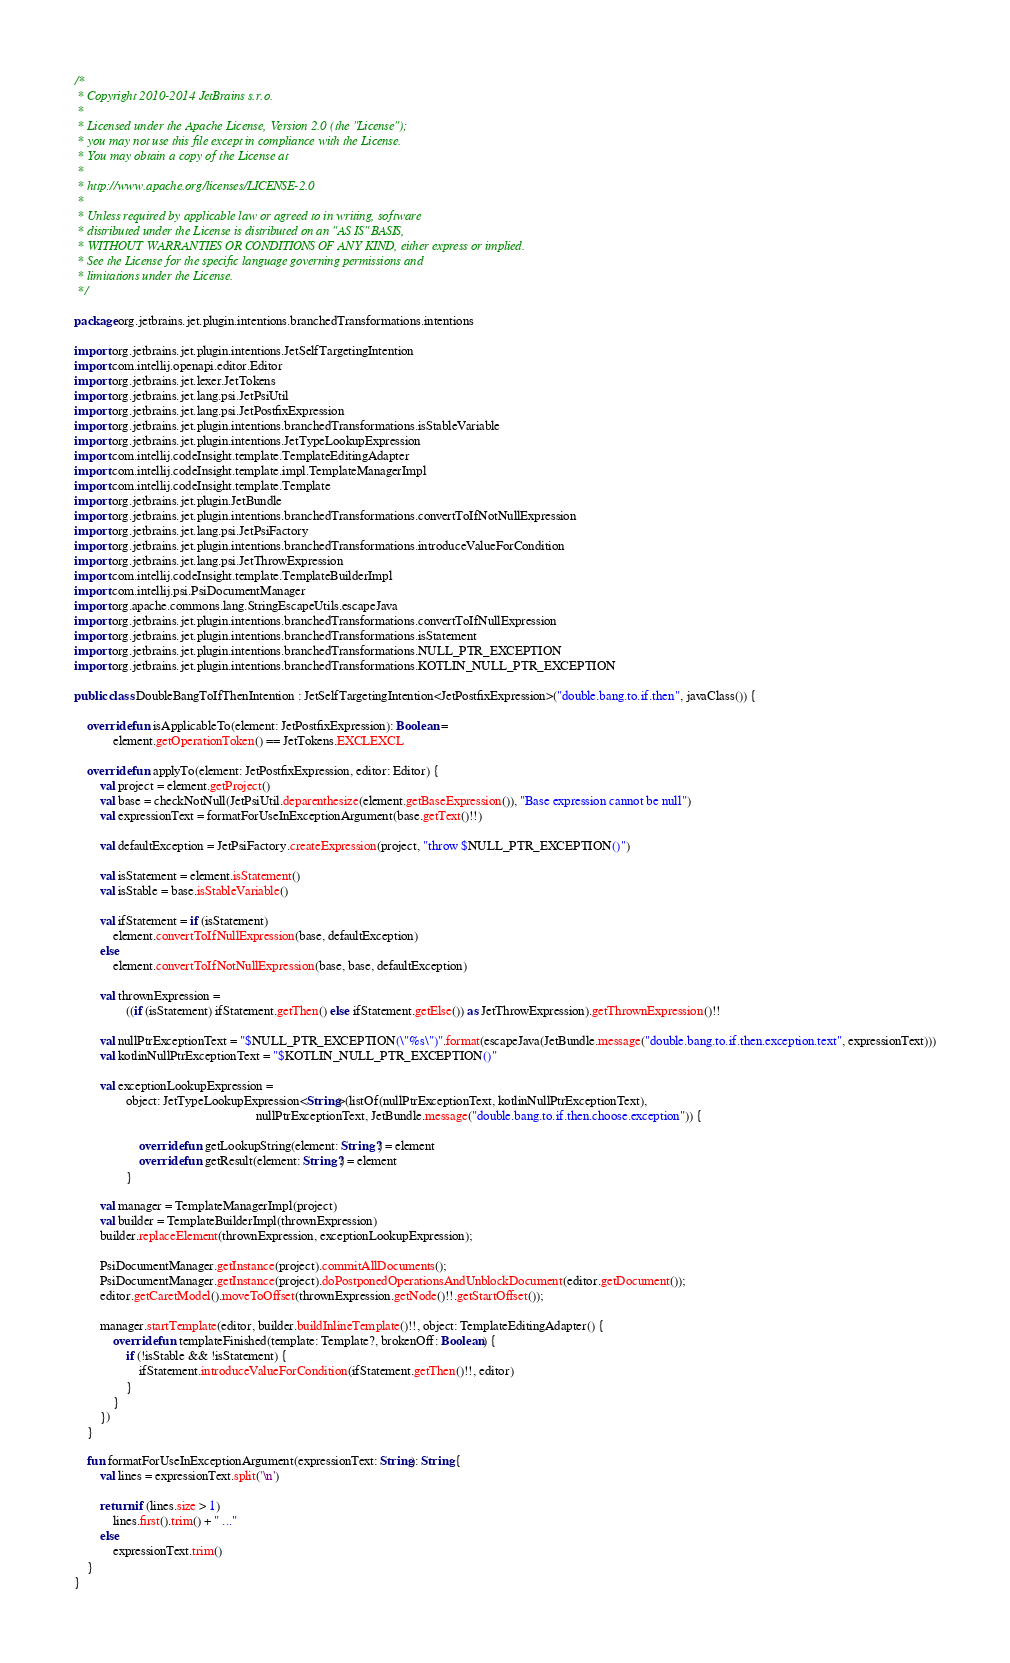<code> <loc_0><loc_0><loc_500><loc_500><_Kotlin_>/*
 * Copyright 2010-2014 JetBrains s.r.o.
 *
 * Licensed under the Apache License, Version 2.0 (the "License");
 * you may not use this file except in compliance with the License.
 * You may obtain a copy of the License at
 *
 * http://www.apache.org/licenses/LICENSE-2.0
 *
 * Unless required by applicable law or agreed to in writing, software
 * distributed under the License is distributed on an "AS IS" BASIS,
 * WITHOUT WARRANTIES OR CONDITIONS OF ANY KIND, either express or implied.
 * See the License for the specific language governing permissions and
 * limitations under the License.
 */

package org.jetbrains.jet.plugin.intentions.branchedTransformations.intentions

import org.jetbrains.jet.plugin.intentions.JetSelfTargetingIntention
import com.intellij.openapi.editor.Editor
import org.jetbrains.jet.lexer.JetTokens
import org.jetbrains.jet.lang.psi.JetPsiUtil
import org.jetbrains.jet.lang.psi.JetPostfixExpression
import org.jetbrains.jet.plugin.intentions.branchedTransformations.isStableVariable
import org.jetbrains.jet.plugin.intentions.JetTypeLookupExpression
import com.intellij.codeInsight.template.TemplateEditingAdapter
import com.intellij.codeInsight.template.impl.TemplateManagerImpl
import com.intellij.codeInsight.template.Template
import org.jetbrains.jet.plugin.JetBundle
import org.jetbrains.jet.plugin.intentions.branchedTransformations.convertToIfNotNullExpression
import org.jetbrains.jet.lang.psi.JetPsiFactory
import org.jetbrains.jet.plugin.intentions.branchedTransformations.introduceValueForCondition
import org.jetbrains.jet.lang.psi.JetThrowExpression
import com.intellij.codeInsight.template.TemplateBuilderImpl
import com.intellij.psi.PsiDocumentManager
import org.apache.commons.lang.StringEscapeUtils.escapeJava
import org.jetbrains.jet.plugin.intentions.branchedTransformations.convertToIfNullExpression
import org.jetbrains.jet.plugin.intentions.branchedTransformations.isStatement
import org.jetbrains.jet.plugin.intentions.branchedTransformations.NULL_PTR_EXCEPTION
import org.jetbrains.jet.plugin.intentions.branchedTransformations.KOTLIN_NULL_PTR_EXCEPTION

public class DoubleBangToIfThenIntention : JetSelfTargetingIntention<JetPostfixExpression>("double.bang.to.if.then", javaClass()) {

    override fun isApplicableTo(element: JetPostfixExpression): Boolean =
            element.getOperationToken() == JetTokens.EXCLEXCL

    override fun applyTo(element: JetPostfixExpression, editor: Editor) {
        val project = element.getProject()
        val base = checkNotNull(JetPsiUtil.deparenthesize(element.getBaseExpression()), "Base expression cannot be null")
        val expressionText = formatForUseInExceptionArgument(base.getText()!!)

        val defaultException = JetPsiFactory.createExpression(project, "throw $NULL_PTR_EXCEPTION()")

        val isStatement = element.isStatement()
        val isStable = base.isStableVariable()

        val ifStatement = if (isStatement)
            element.convertToIfNullExpression(base, defaultException)
        else
            element.convertToIfNotNullExpression(base, base, defaultException)

        val thrownExpression =
                ((if (isStatement) ifStatement.getThen() else ifStatement.getElse()) as JetThrowExpression).getThrownExpression()!!

        val nullPtrExceptionText = "$NULL_PTR_EXCEPTION(\"%s\")".format(escapeJava(JetBundle.message("double.bang.to.if.then.exception.text", expressionText)))
        val kotlinNullPtrExceptionText = "$KOTLIN_NULL_PTR_EXCEPTION()"

        val exceptionLookupExpression =
                object: JetTypeLookupExpression<String>(listOf(nullPtrExceptionText, kotlinNullPtrExceptionText),
                                                        nullPtrExceptionText, JetBundle.message("double.bang.to.if.then.choose.exception")) {

                    override fun getLookupString(element: String?) = element
                    override fun getResult(element: String?) = element
                }

        val manager = TemplateManagerImpl(project)
        val builder = TemplateBuilderImpl(thrownExpression)
        builder.replaceElement(thrownExpression, exceptionLookupExpression);

        PsiDocumentManager.getInstance(project).commitAllDocuments();
        PsiDocumentManager.getInstance(project).doPostponedOperationsAndUnblockDocument(editor.getDocument());
        editor.getCaretModel().moveToOffset(thrownExpression.getNode()!!.getStartOffset());

        manager.startTemplate(editor, builder.buildInlineTemplate()!!, object: TemplateEditingAdapter() {
            override fun templateFinished(template: Template?, brokenOff: Boolean) {
                if (!isStable && !isStatement) {
                    ifStatement.introduceValueForCondition(ifStatement.getThen()!!, editor)
                }
            }
        })
    }

    fun formatForUseInExceptionArgument(expressionText: String): String {
        val lines = expressionText.split('\n')

        return if (lines.size > 1)
            lines.first().trim() + " ..."
        else
            expressionText.trim()
    }
}
</code> 